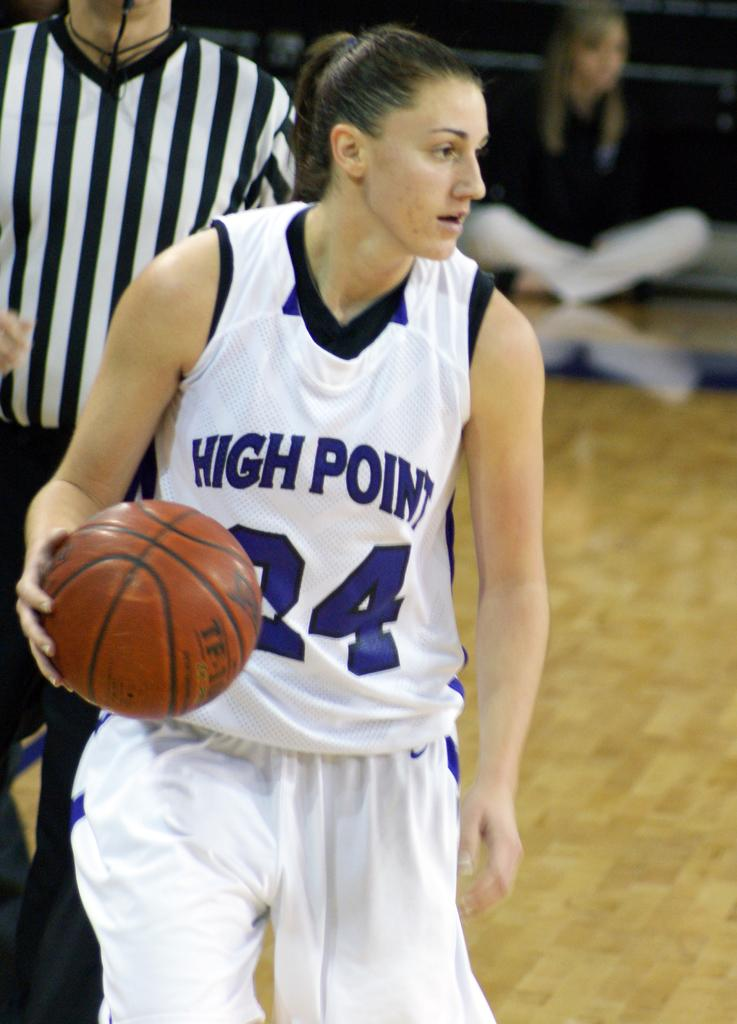<image>
Relay a brief, clear account of the picture shown. women playing a basketball game from high point 